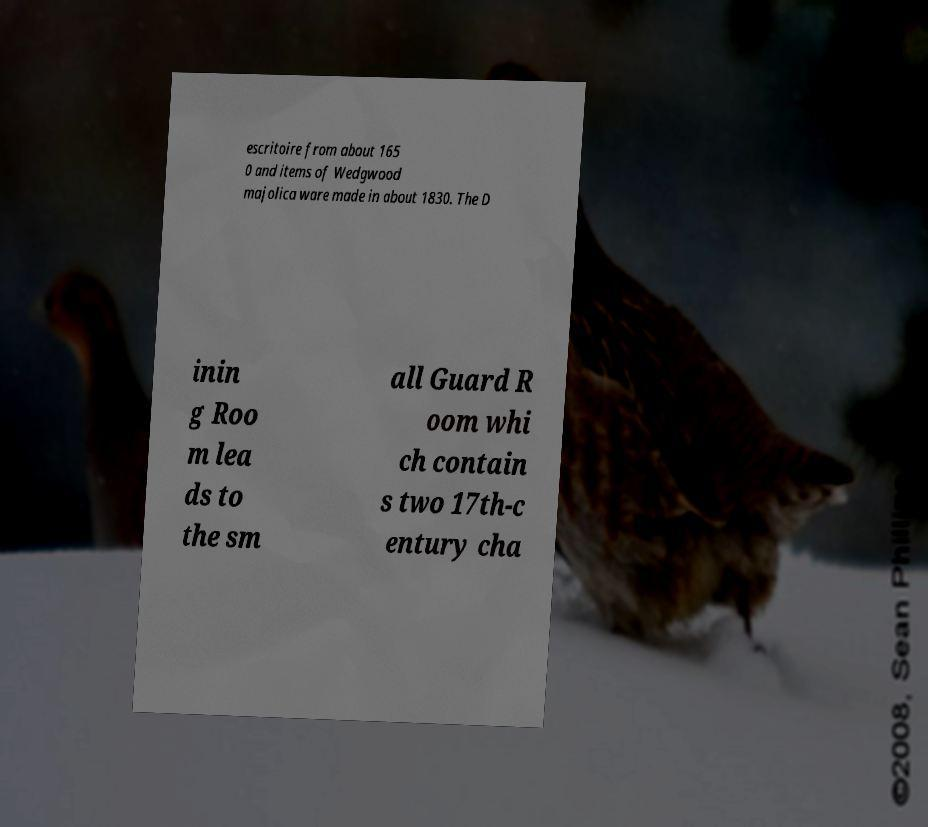Please read and relay the text visible in this image. What does it say? escritoire from about 165 0 and items of Wedgwood majolica ware made in about 1830. The D inin g Roo m lea ds to the sm all Guard R oom whi ch contain s two 17th-c entury cha 